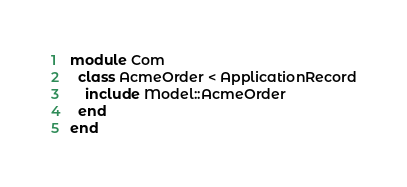Convert code to text. <code><loc_0><loc_0><loc_500><loc_500><_Ruby_>module Com
  class AcmeOrder < ApplicationRecord
    include Model::AcmeOrder
  end
end
</code> 